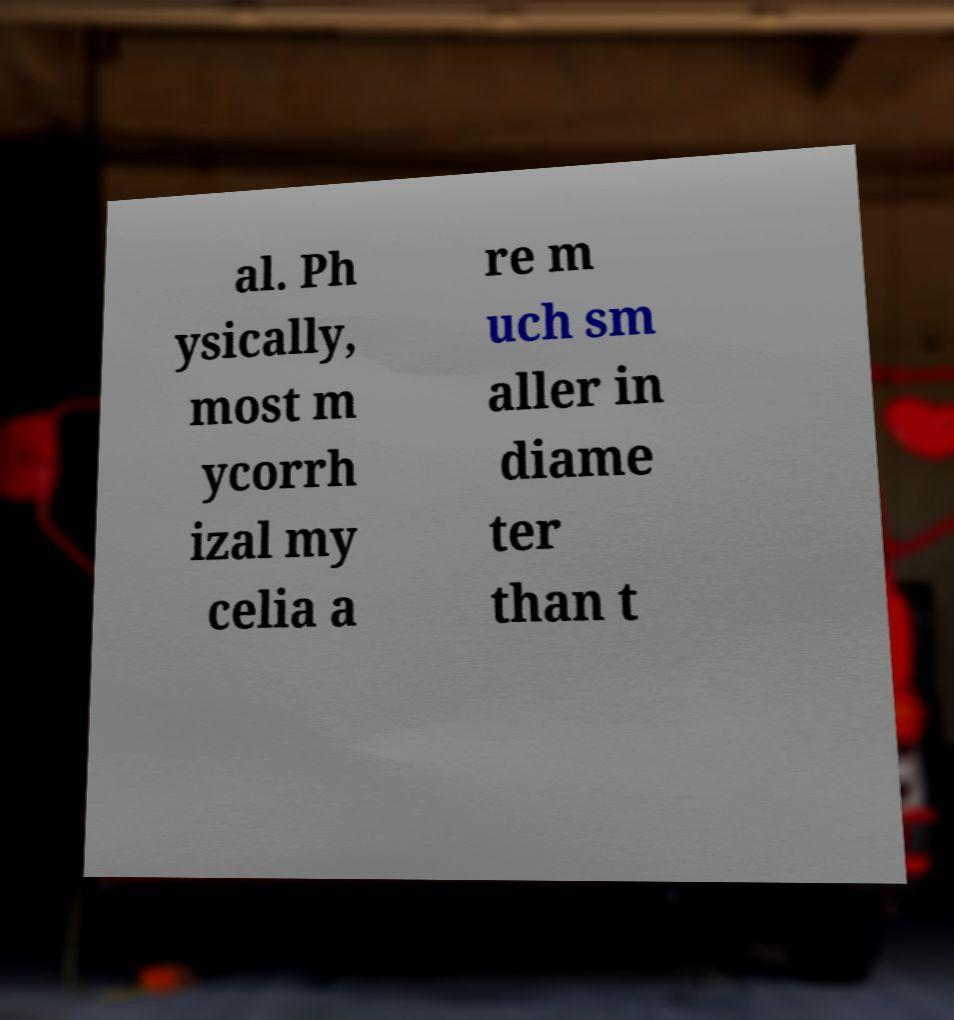Please identify and transcribe the text found in this image. al. Ph ysically, most m ycorrh izal my celia a re m uch sm aller in diame ter than t 